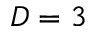<formula> <loc_0><loc_0><loc_500><loc_500>D = 3</formula> 